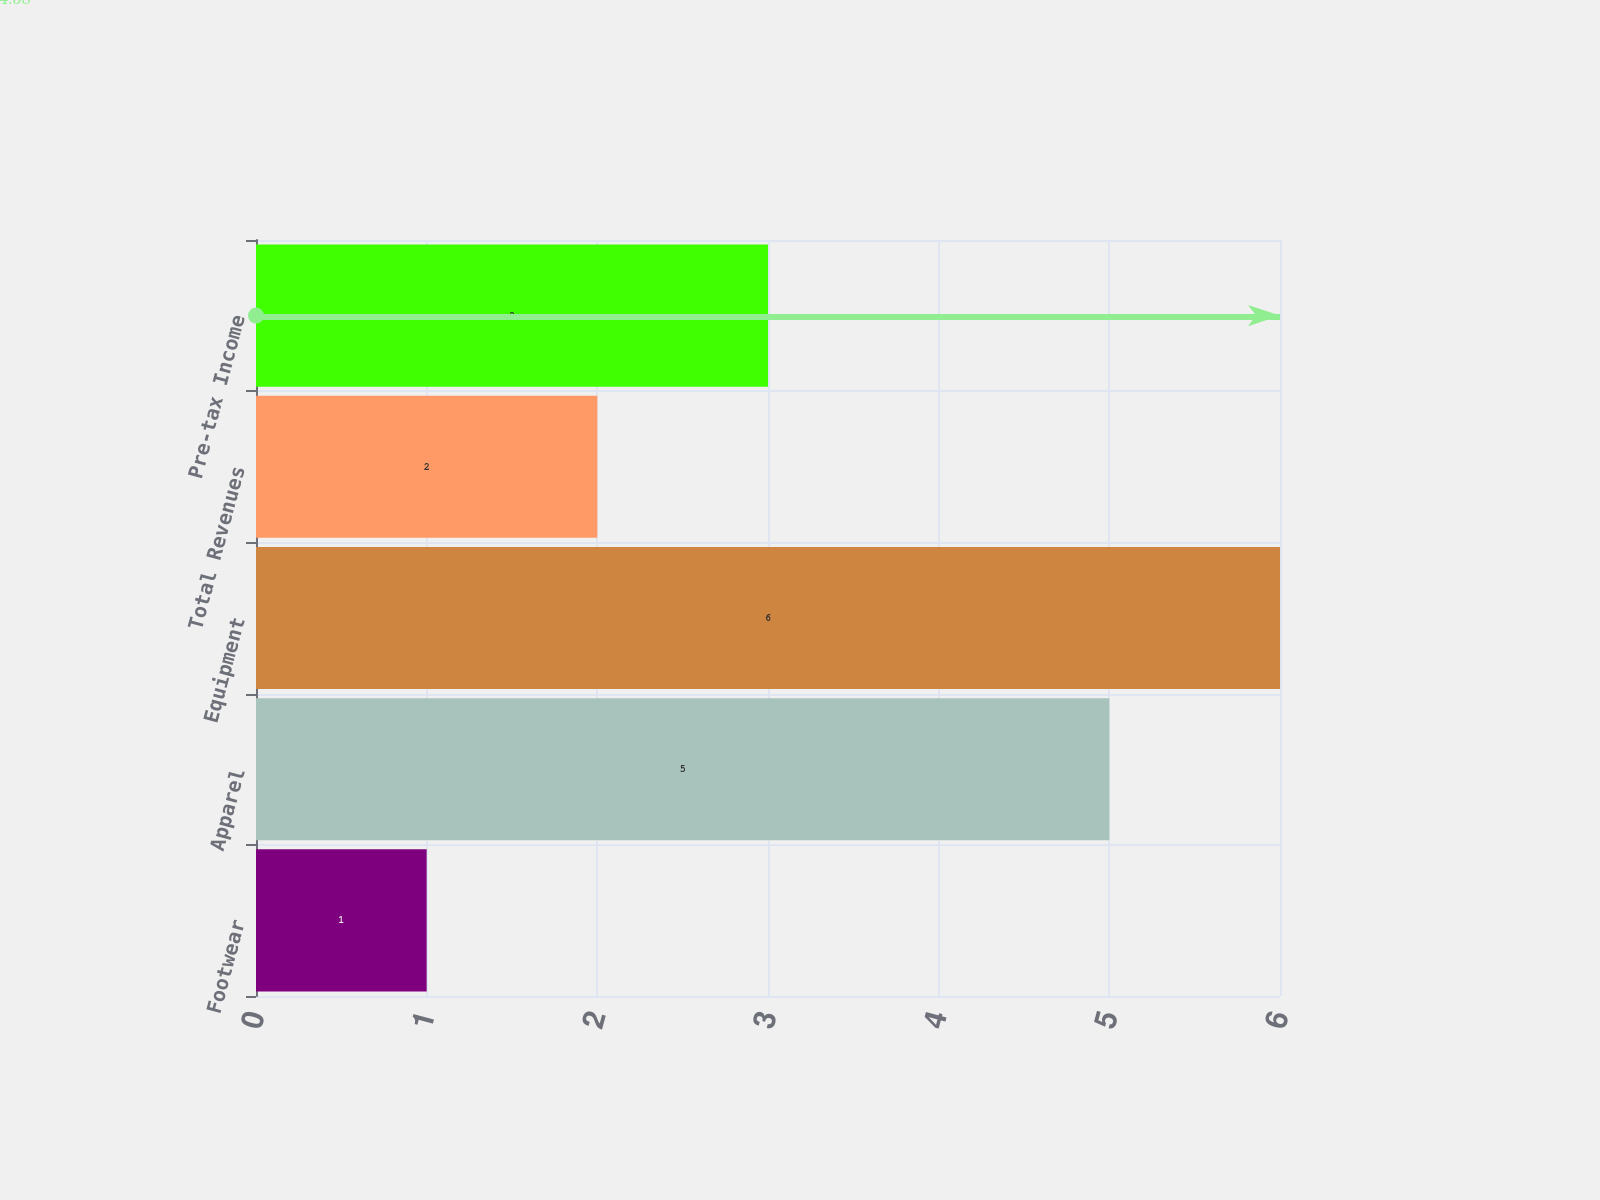<chart> <loc_0><loc_0><loc_500><loc_500><bar_chart><fcel>Footwear<fcel>Apparel<fcel>Equipment<fcel>Total Revenues<fcel>Pre-tax Income<nl><fcel>1<fcel>5<fcel>6<fcel>2<fcel>3<nl></chart> 